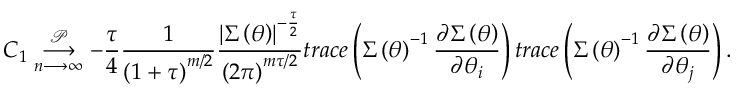<formula> <loc_0><loc_0><loc_500><loc_500>C _ { 1 } \underset { n \longrightarrow \infty } { \overset { \mathcal { P } } { \longrightarrow } } - \frac { \tau } { 4 } \frac { 1 } { \left ( 1 + \tau \right ) ^ { m / 2 } } \frac { \left | \Sigma \left ( \theta \right ) \right | ^ { - \frac { \tau } { 2 } } } { \left ( 2 \pi \right ) ^ { m \tau / 2 } } t r a c e \left ( \Sigma \left ( \theta \right ) ^ { - 1 } \frac { \partial \Sigma \left ( \theta \right ) } { \partial \theta _ { i } } \right ) t r a c e \left ( \Sigma \left ( \theta \right ) ^ { - 1 } \frac { \partial \Sigma \left ( \theta \right ) } { \partial \theta _ { j } } \right ) .</formula> 